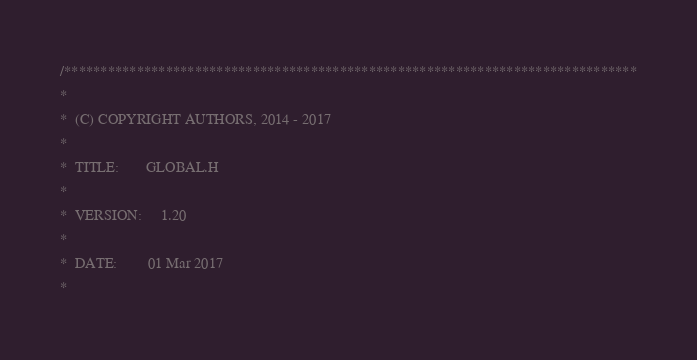Convert code to text. <code><loc_0><loc_0><loc_500><loc_500><_C_>/*******************************************************************************
*
*  (C) COPYRIGHT AUTHORS, 2014 - 2017
*
*  TITLE:       GLOBAL.H
*
*  VERSION:     1.20
*
*  DATE:        01 Mar 2017
*</code> 